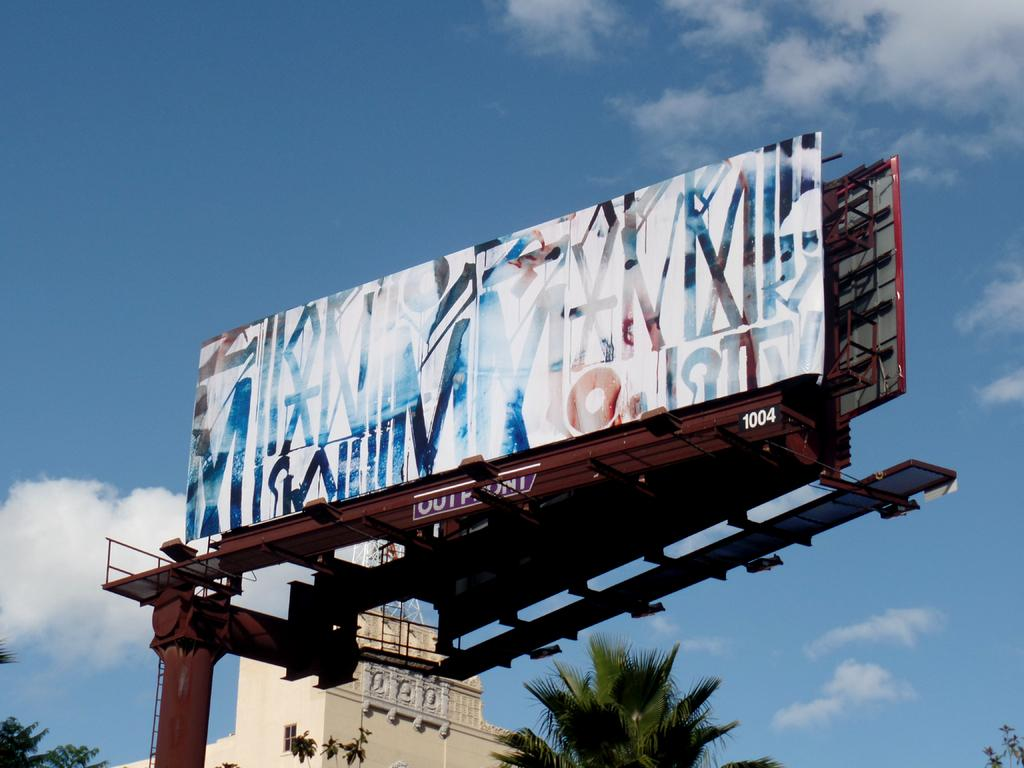Provide a one-sentence caption for the provided image. A billboard sits on a frame that is numbered 1004. 